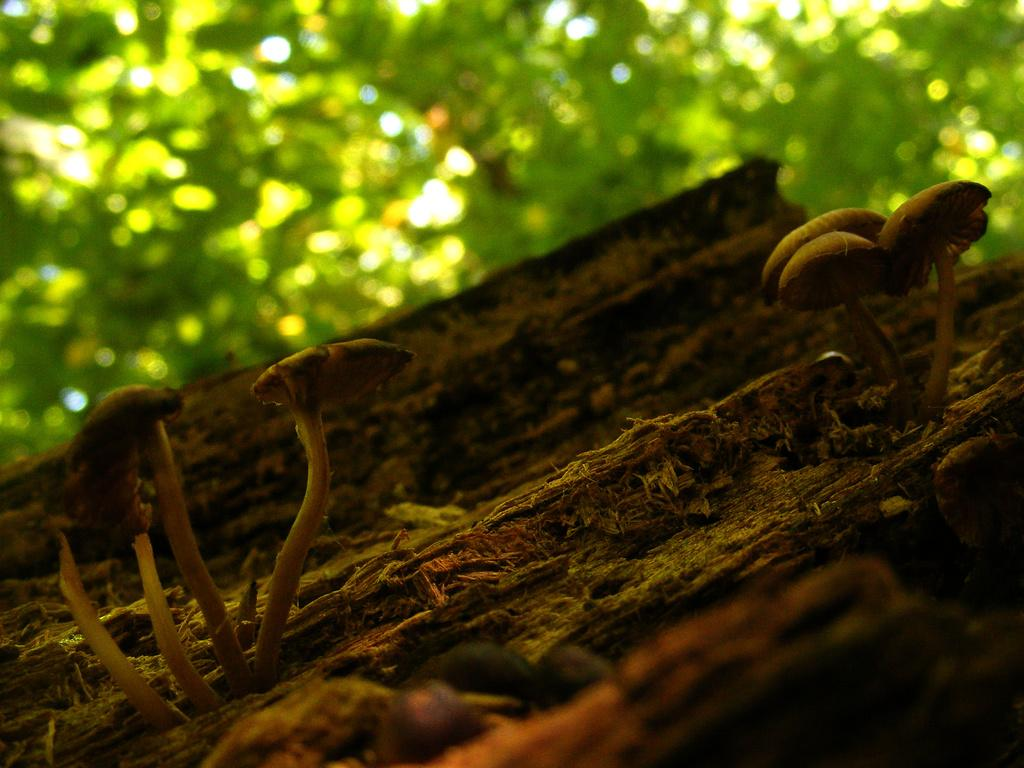What is growing on the tree bark in the image? There are mushrooms on a tree bark in the image. What can be seen in the background of the image? There are trees in the background of the image. What type of shoes are hanging from the tree in the image? There are no shoes present in the image; it only features mushrooms on a tree bark and trees in the background. 